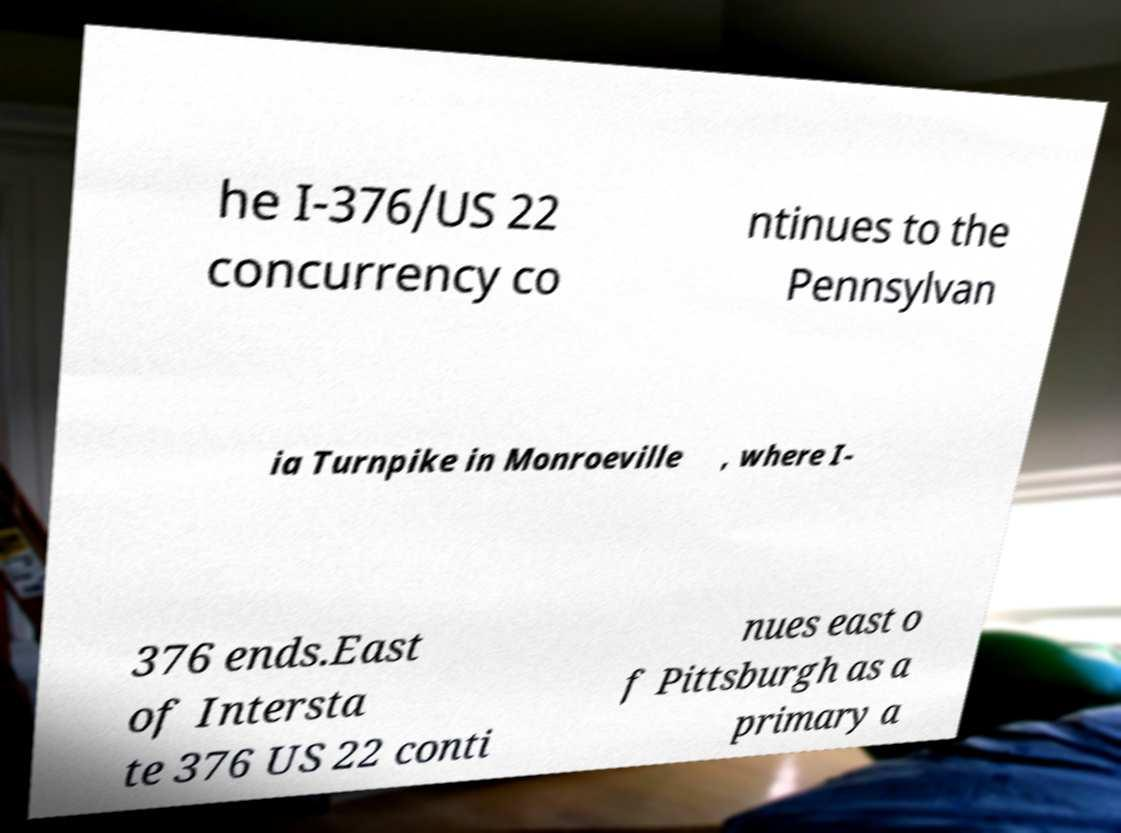Could you assist in decoding the text presented in this image and type it out clearly? he I-376/US 22 concurrency co ntinues to the Pennsylvan ia Turnpike in Monroeville , where I- 376 ends.East of Intersta te 376 US 22 conti nues east o f Pittsburgh as a primary a 